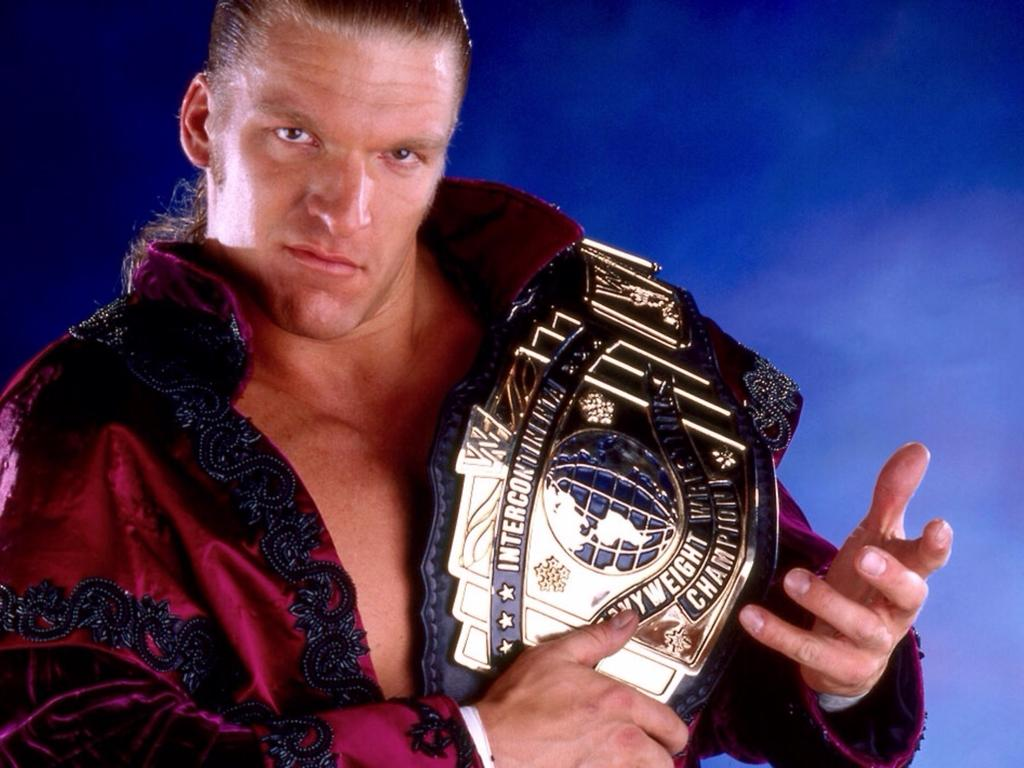<image>
Summarize the visual content of the image. A man holds a heavy weight championship belt. 